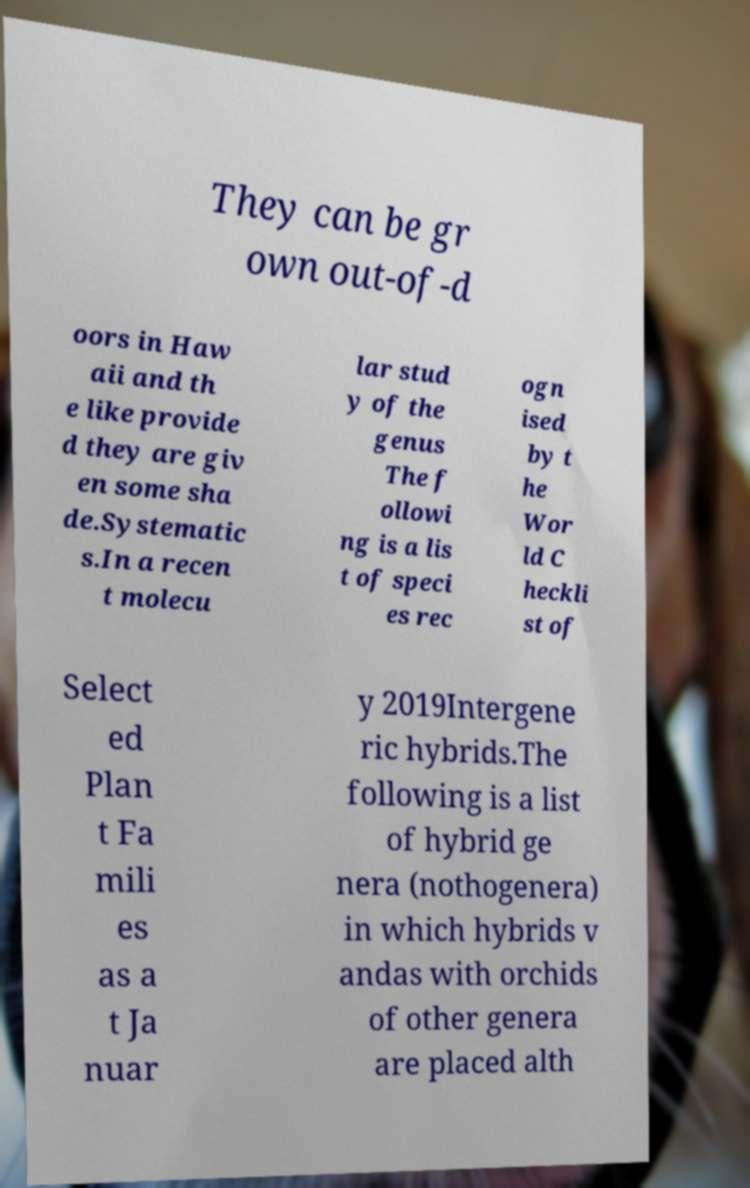What messages or text are displayed in this image? I need them in a readable, typed format. They can be gr own out-of-d oors in Haw aii and th e like provide d they are giv en some sha de.Systematic s.In a recen t molecu lar stud y of the genus The f ollowi ng is a lis t of speci es rec ogn ised by t he Wor ld C heckli st of Select ed Plan t Fa mili es as a t Ja nuar y 2019Intergene ric hybrids.The following is a list of hybrid ge nera (nothogenera) in which hybrids v andas with orchids of other genera are placed alth 